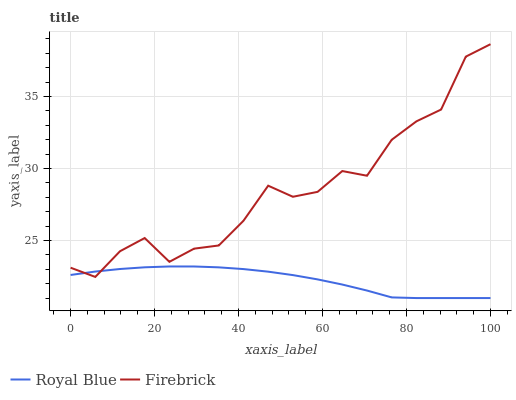Does Firebrick have the minimum area under the curve?
Answer yes or no. No. Is Firebrick the smoothest?
Answer yes or no. No. Does Firebrick have the lowest value?
Answer yes or no. No. 